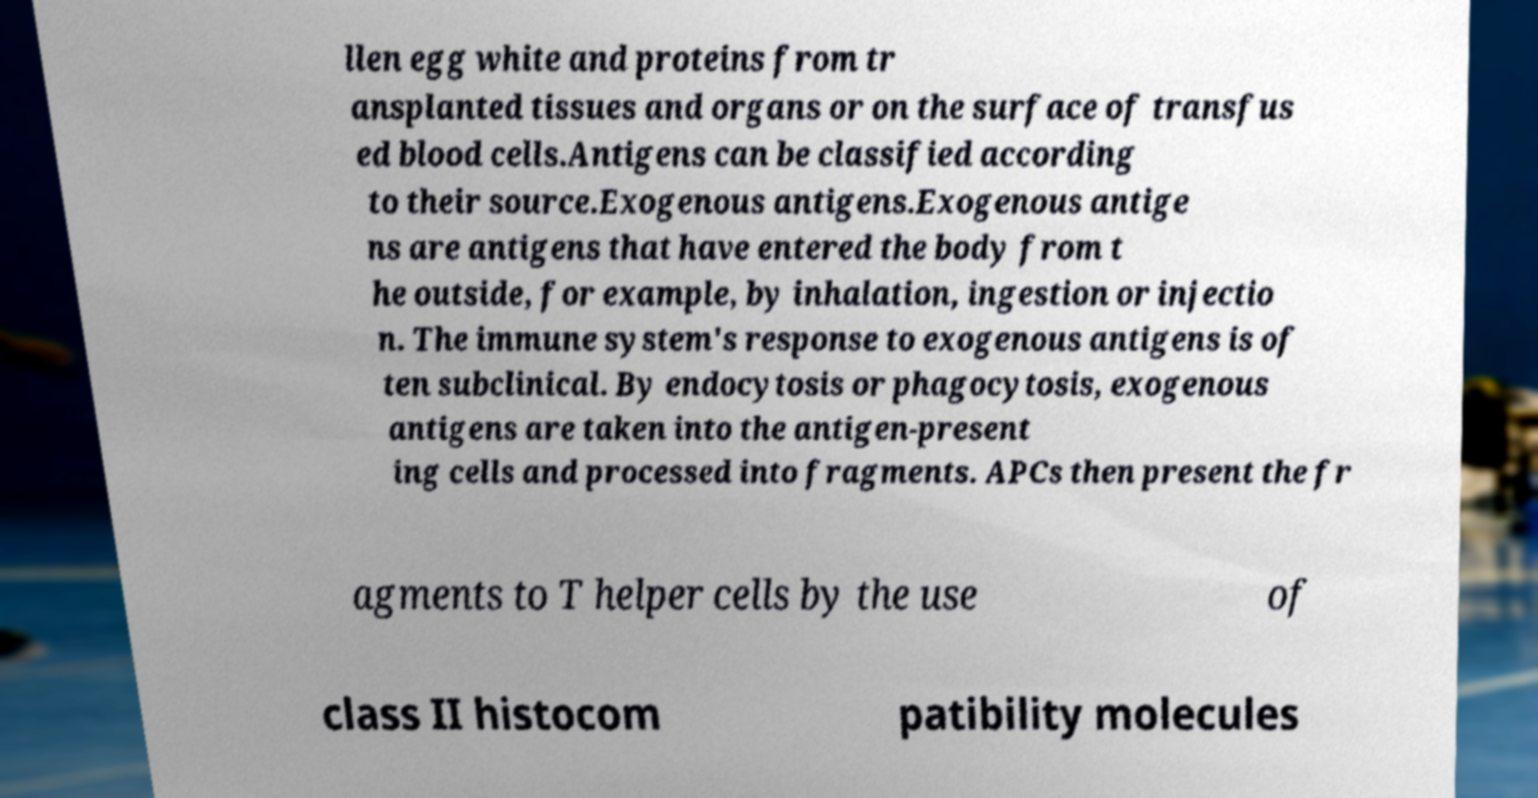Can you accurately transcribe the text from the provided image for me? llen egg white and proteins from tr ansplanted tissues and organs or on the surface of transfus ed blood cells.Antigens can be classified according to their source.Exogenous antigens.Exogenous antige ns are antigens that have entered the body from t he outside, for example, by inhalation, ingestion or injectio n. The immune system's response to exogenous antigens is of ten subclinical. By endocytosis or phagocytosis, exogenous antigens are taken into the antigen-present ing cells and processed into fragments. APCs then present the fr agments to T helper cells by the use of class II histocom patibility molecules 